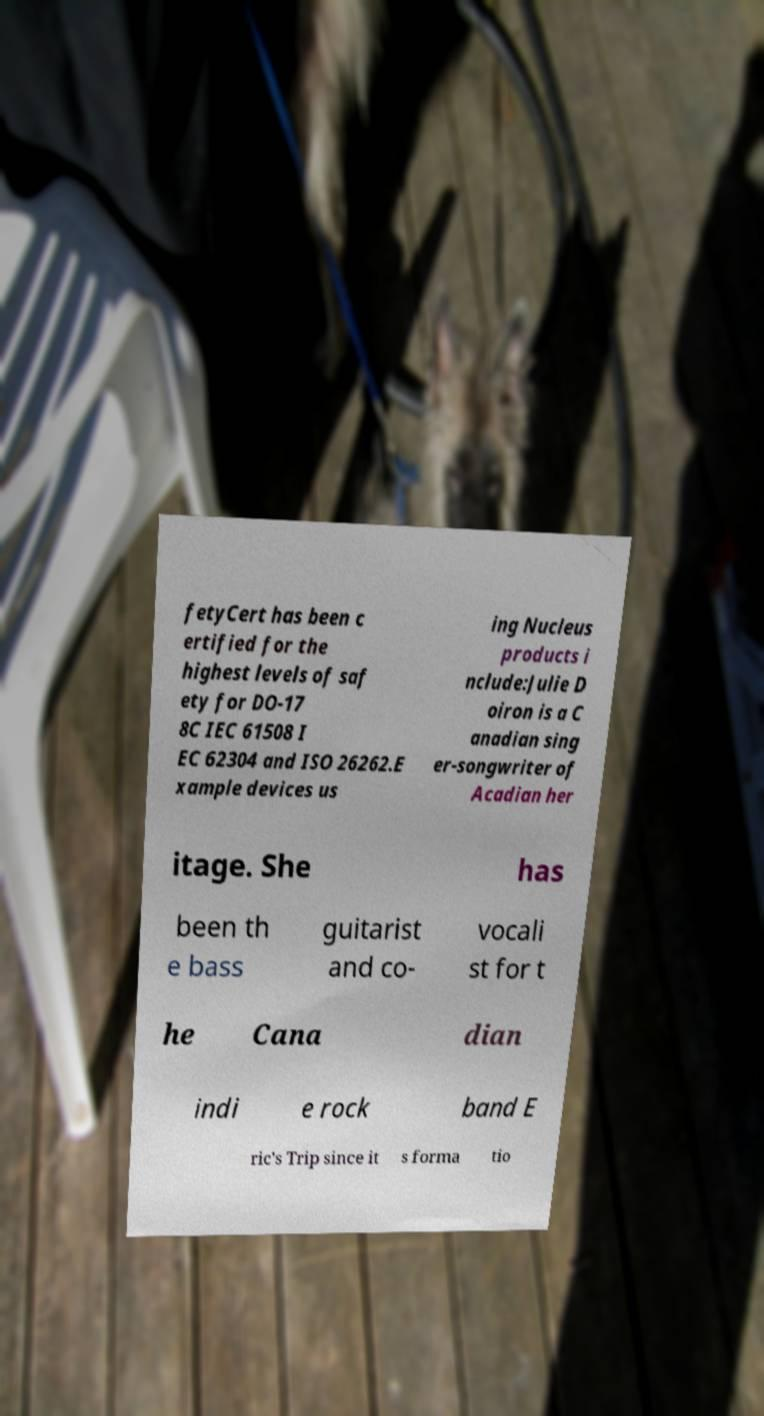Can you accurately transcribe the text from the provided image for me? fetyCert has been c ertified for the highest levels of saf ety for DO-17 8C IEC 61508 I EC 62304 and ISO 26262.E xample devices us ing Nucleus products i nclude:Julie D oiron is a C anadian sing er-songwriter of Acadian her itage. She has been th e bass guitarist and co- vocali st for t he Cana dian indi e rock band E ric's Trip since it s forma tio 